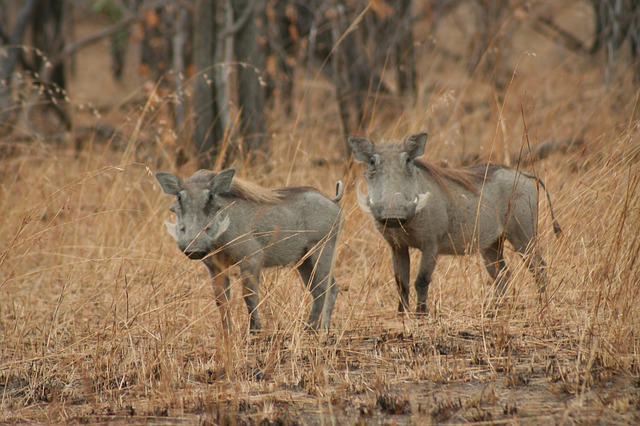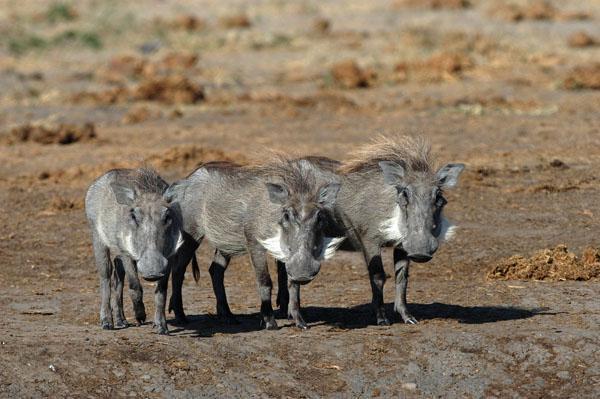The first image is the image on the left, the second image is the image on the right. Analyze the images presented: Is the assertion "the left image has at most 2 wartgogs" valid? Answer yes or no. Yes. The first image is the image on the left, the second image is the image on the right. For the images displayed, is the sentence "In one image there are at least two warthogs drinking out of a pond." factually correct? Answer yes or no. No. 